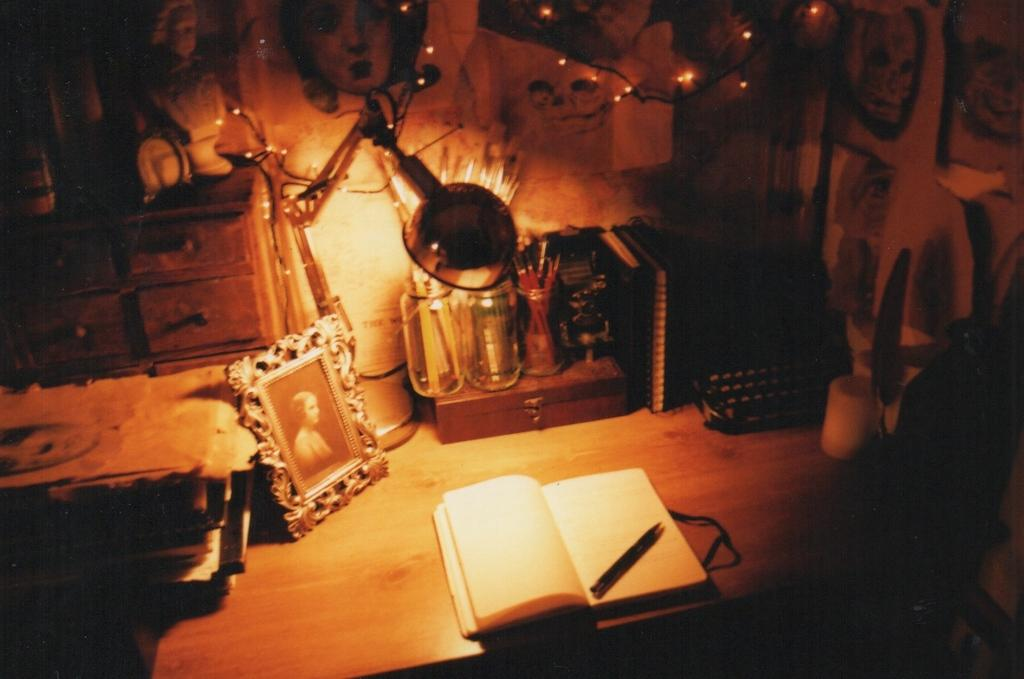What piece of furniture is present in the image? There is a table in the image. What items can be seen on the table? There is a book, a pen, and a photo frame on the table. Can you describe any other objects on the table? There are some objects on the table, but their specific details are not mentioned in the facts. Is there a swing in the image? No, there is no swing present in the image. Can you tell me the color of the apple on the table? There is no apple present in the image. 